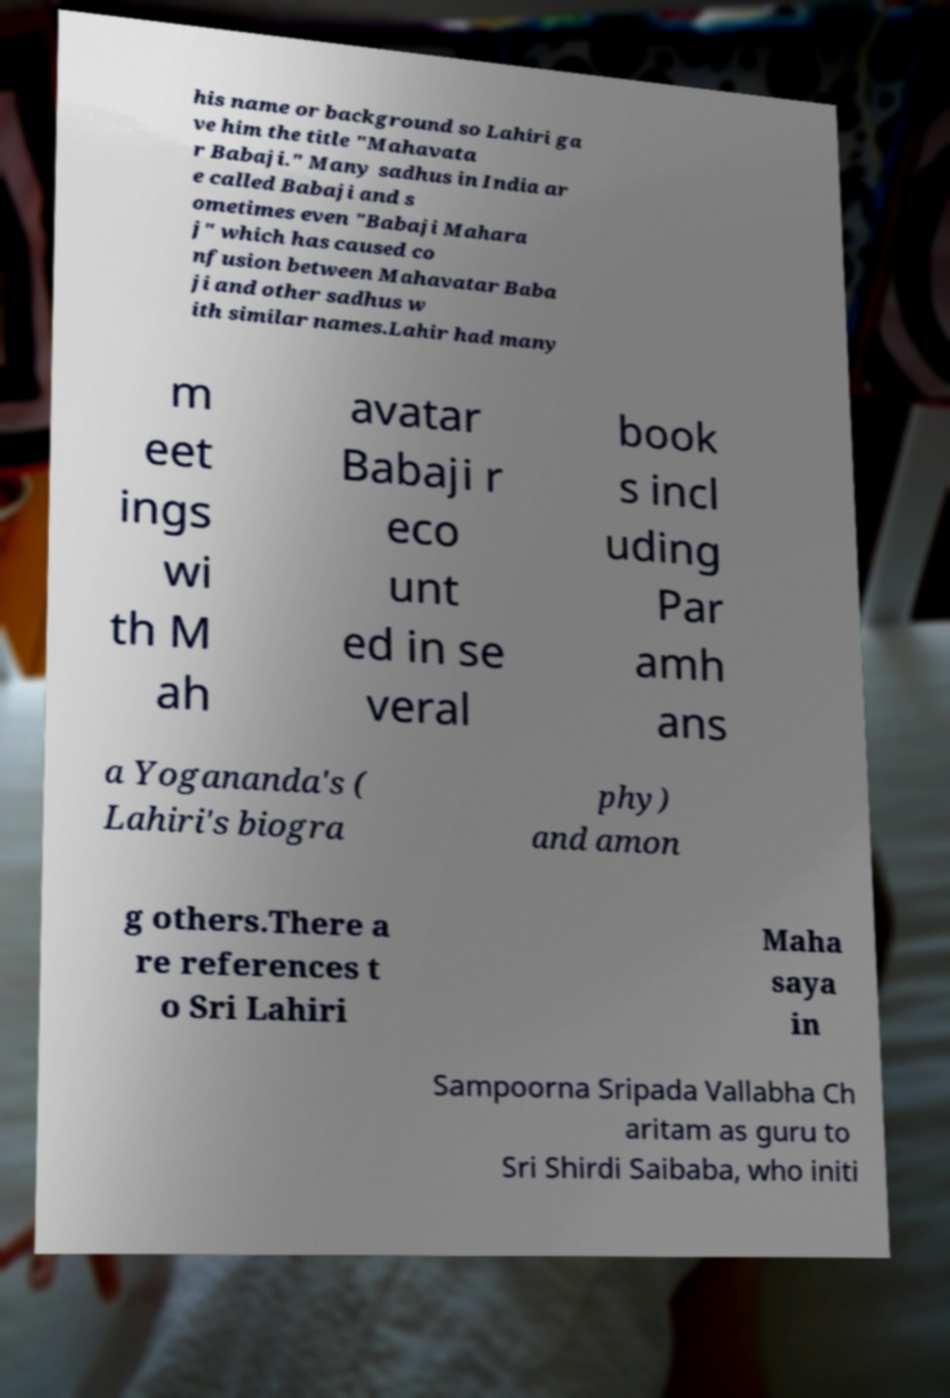Could you extract and type out the text from this image? his name or background so Lahiri ga ve him the title "Mahavata r Babaji." Many sadhus in India ar e called Babaji and s ometimes even "Babaji Mahara j" which has caused co nfusion between Mahavatar Baba ji and other sadhus w ith similar names.Lahir had many m eet ings wi th M ah avatar Babaji r eco unt ed in se veral book s incl uding Par amh ans a Yogananda's ( Lahiri's biogra phy) and amon g others.There a re references t o Sri Lahiri Maha saya in Sampoorna Sripada Vallabha Ch aritam as guru to Sri Shirdi Saibaba, who initi 